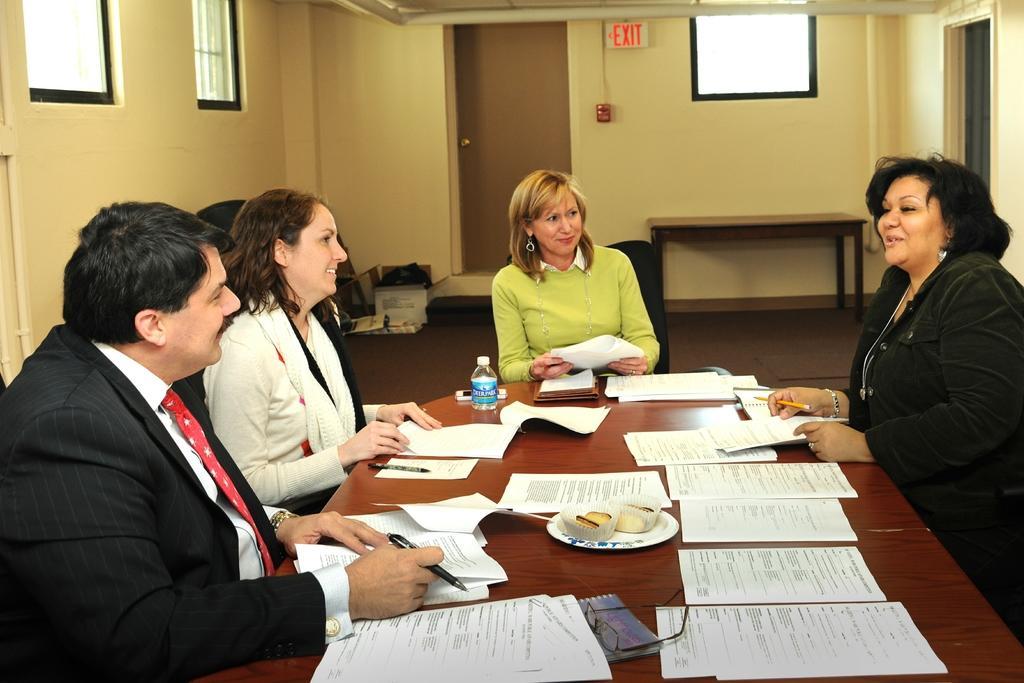Could you give a brief overview of what you see in this image? In this image in the center there is a table and on the table there are papers, there is a bottle and there is a mobile phone and there is food on the plate. On the left side of the table there are two persons sitting and smiling and the man holding a pen in his hand. On the right side of the table there is a woman sitting and smiling and holding a pen and paper in her hand. In the background there is a woman sitting on the chair holding a paper in her hand and smiling and there is an empty table and there are objects on the floor which are white and black in colour and there is a door and there is a board with some text written on it and there is a window. On the left side there are windows and on the right side there is a door. 